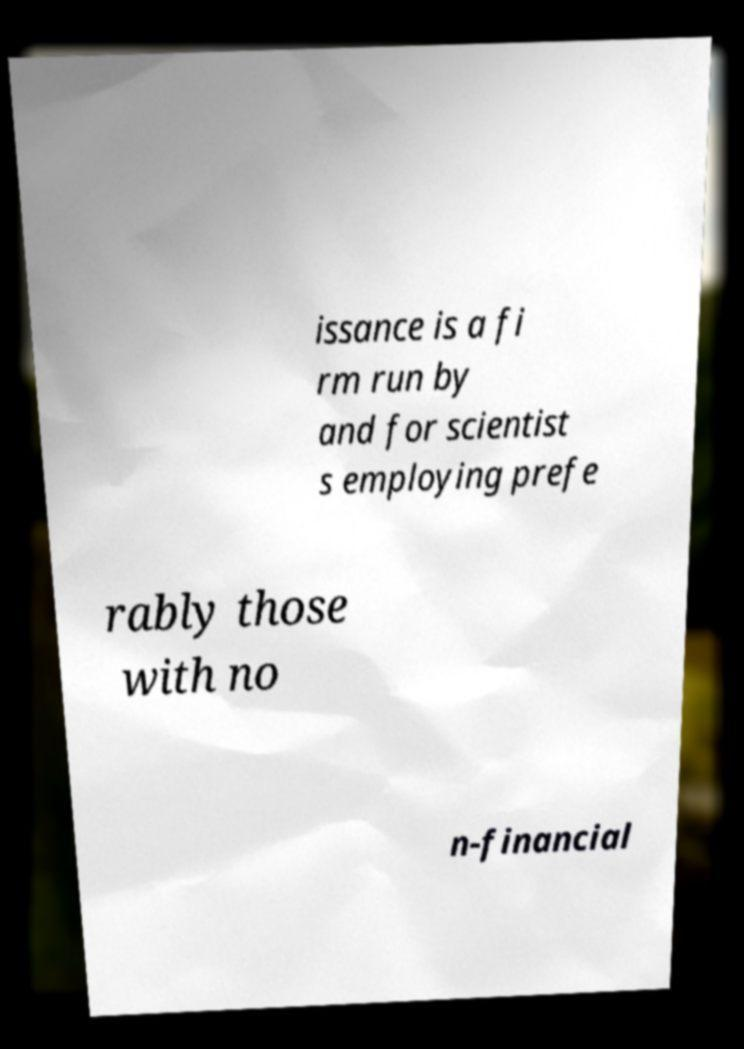What messages or text are displayed in this image? I need them in a readable, typed format. issance is a fi rm run by and for scientist s employing prefe rably those with no n-financial 